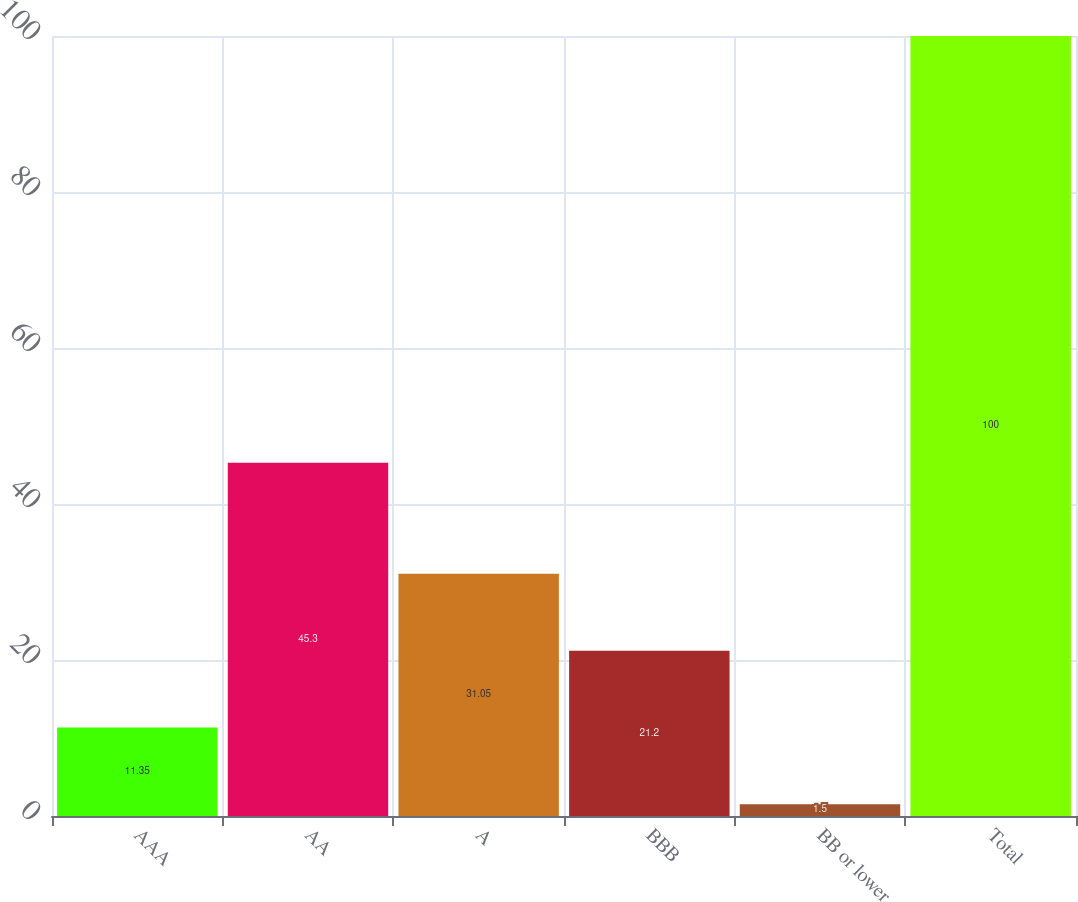Convert chart. <chart><loc_0><loc_0><loc_500><loc_500><bar_chart><fcel>AAA<fcel>AA<fcel>A<fcel>BBB<fcel>BB or lower<fcel>Total<nl><fcel>11.35<fcel>45.3<fcel>31.05<fcel>21.2<fcel>1.5<fcel>100<nl></chart> 